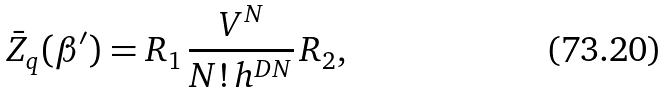<formula> <loc_0><loc_0><loc_500><loc_500>\bar { Z } _ { q } ( \beta ^ { \prime } ) = R _ { 1 } \, \frac { V ^ { N } } { N ! \, h ^ { D N } } \, R _ { 2 } ,</formula> 